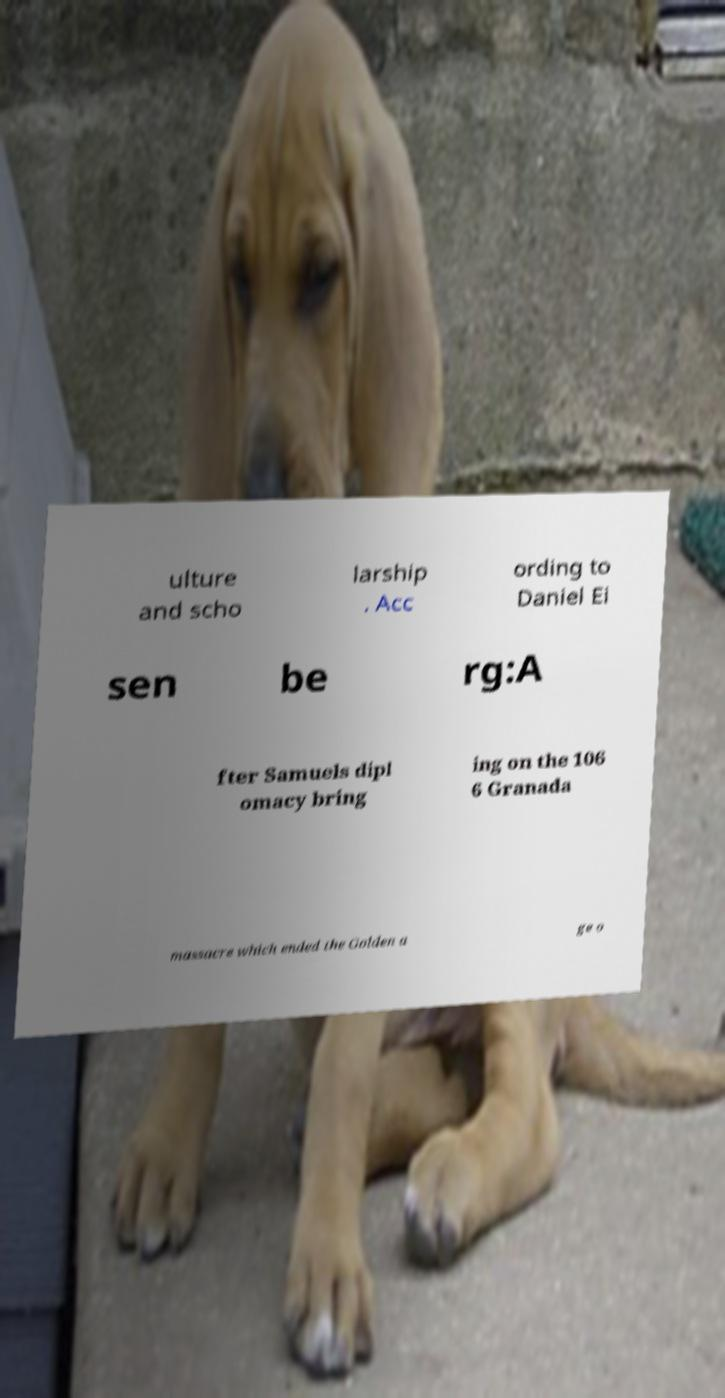For documentation purposes, I need the text within this image transcribed. Could you provide that? ulture and scho larship . Acc ording to Daniel Ei sen be rg:A fter Samuels dipl omacy bring ing on the 106 6 Granada massacre which ended the Golden a ge o 